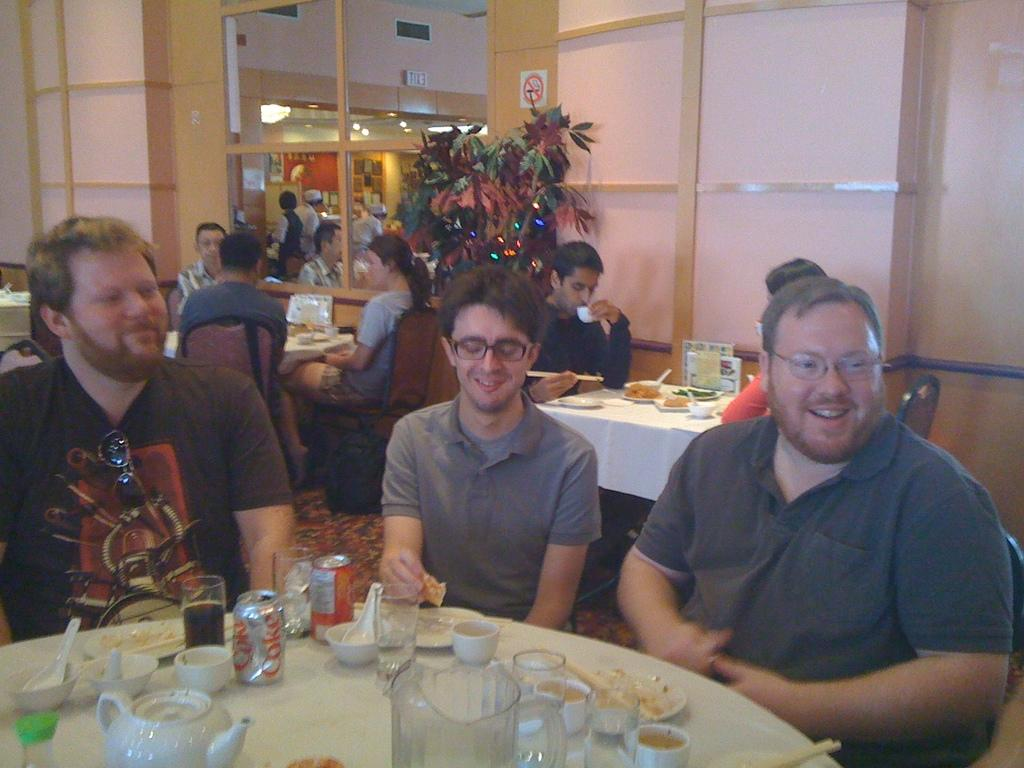What are the people in the image doing? The people in the image are sitting on chairs. How are the chairs arranged in the image? The chairs are arranged around a table. What can be found on the table in the image? There are some things on the table. What is located beside the table in the image? There is a plant beside the table. What type of butter is being used by the people sitting on chairs in the image? There is no butter present in the image; the people are sitting on chairs around a table with some things on it. 